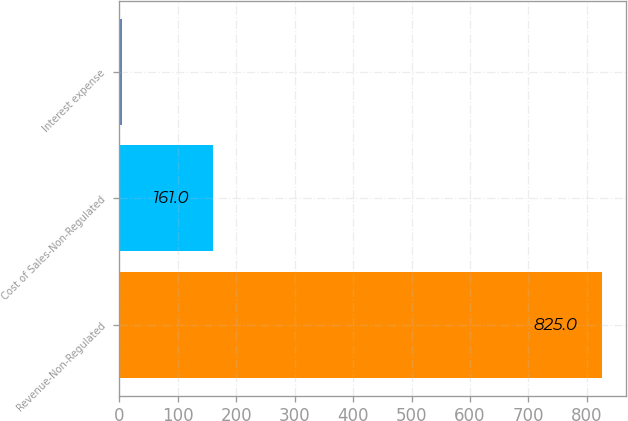Convert chart to OTSL. <chart><loc_0><loc_0><loc_500><loc_500><bar_chart><fcel>Revenue-Non-Regulated<fcel>Cost of Sales-Non-Regulated<fcel>Interest expense<nl><fcel>825<fcel>161<fcel>5<nl></chart> 